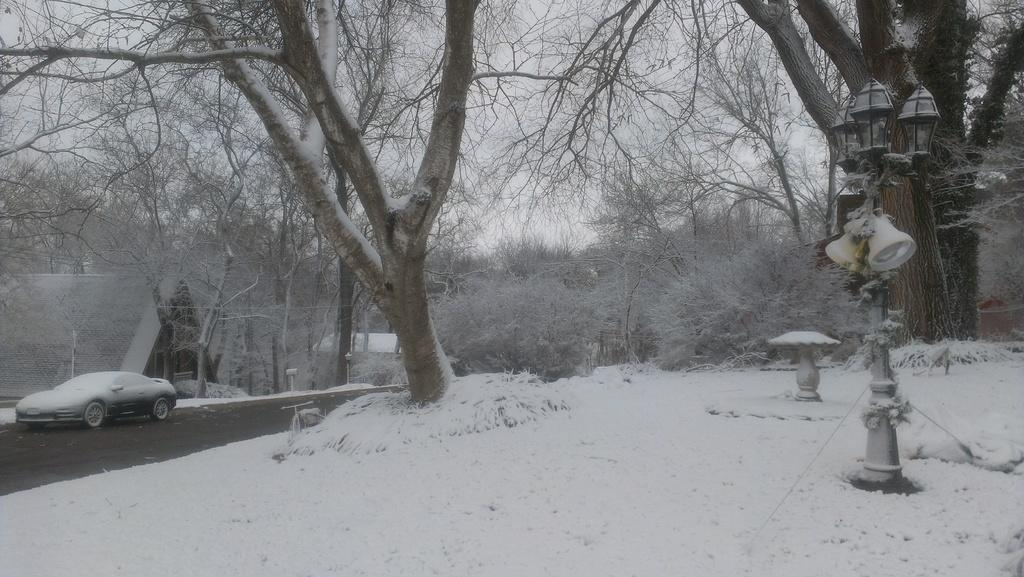What type of weather is depicted in the image? There is snow in the image, indicating a winter scene. What natural elements can be seen in the image? There are trees in the image. What man-made structures are present in the image? There is a road, a car, and houses in the image. What is visible in the sky in the image? The sky is visible in the image. What type of soda is being advertised on the side of the car in the image? There is no soda or advertisement present on the side of the car in the image. Can you tell me how many wrenches are lying on the road in the image? There are no wrenches visible on the road in the image. 